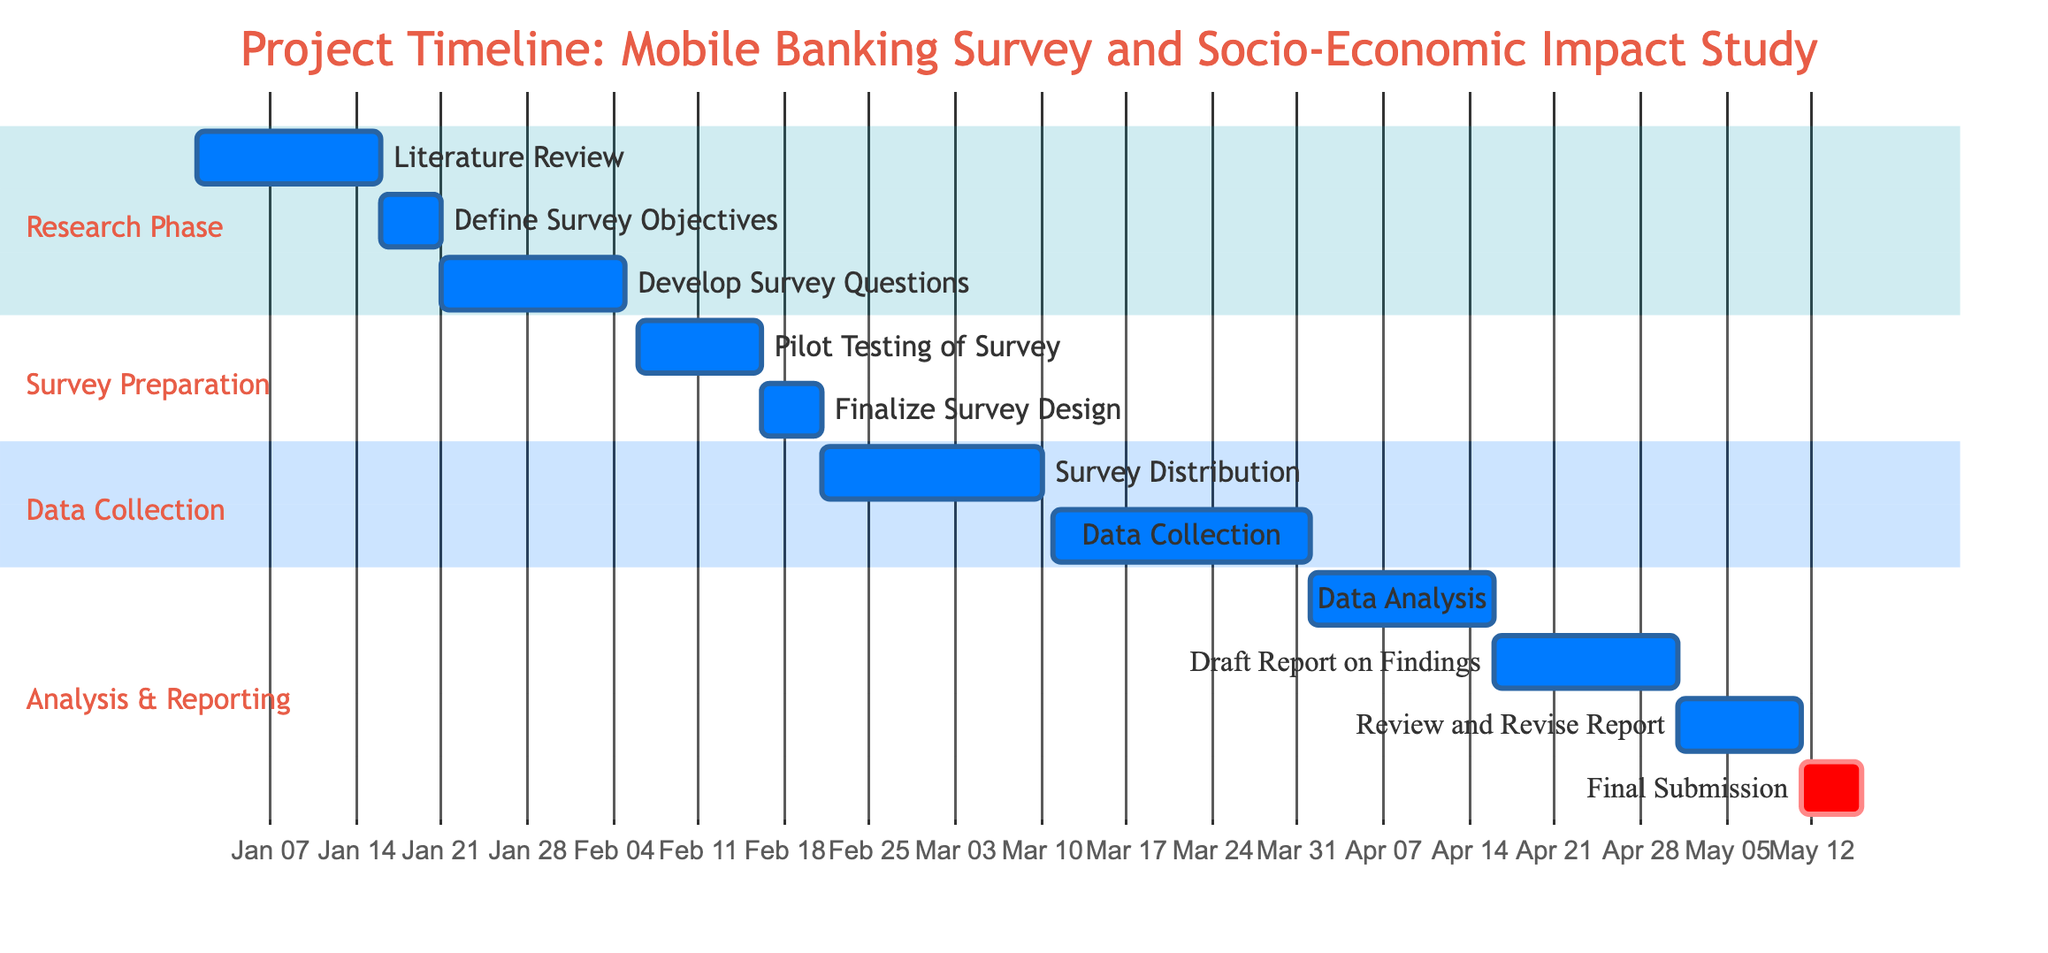What is the duration of the "Literature Review" task? The "Literature Review" task has a duration of 15 days, as stated directly on the diagram.
Answer: 15 days What task follows "Define Survey Objectives"? The task that follows "Define Survey Objectives" is "Develop Survey Questions," which begins immediately after the previous task ends.
Answer: Develop Survey Questions How many tasks are completed before the "Survey Distribution"? There are three tasks completed before "Survey Distribution": "Literature Review," "Define Survey Objectives," and "Develop Survey Questions."
Answer: Three When does the "Data Collection" phase start? The "Data Collection" phase starts on March 11, 2024, as shown in the diagram where it lists the start date for this task.
Answer: March 11, 2024 Which task has the longest duration in the "Analysis & Reporting" section? The task with the longest duration in the "Analysis & Reporting" section is "Draft Report on Findings," which lasts for 15 days.
Answer: Draft Report on Findings What is the total duration for the "Survey Preparation" section? The "Survey Preparation" section includes two tasks: "Pilot Testing of Survey" for 10 days and "Finalize Survey Design" for 5 days, totaling 15 days.
Answer: 15 days Which task ends last in the project timeline? The last task to end in the project timeline is "Final Submission," which concludes on May 15, 2024, as indicated in the timeline's final entry.
Answer: May 15, 2024 What is the gap between the "Data Analysis" task and the "Draft Report on Findings"? There is no gap; "Data Analysis" ends on April 15, and "Draft Report on Findings" starts the next day, April 16.
Answer: No gap How many days does the "Review and Revise Report" task take? The "Review and Revise Report" task takes 10 days, as specified in the diagram.
Answer: 10 days 